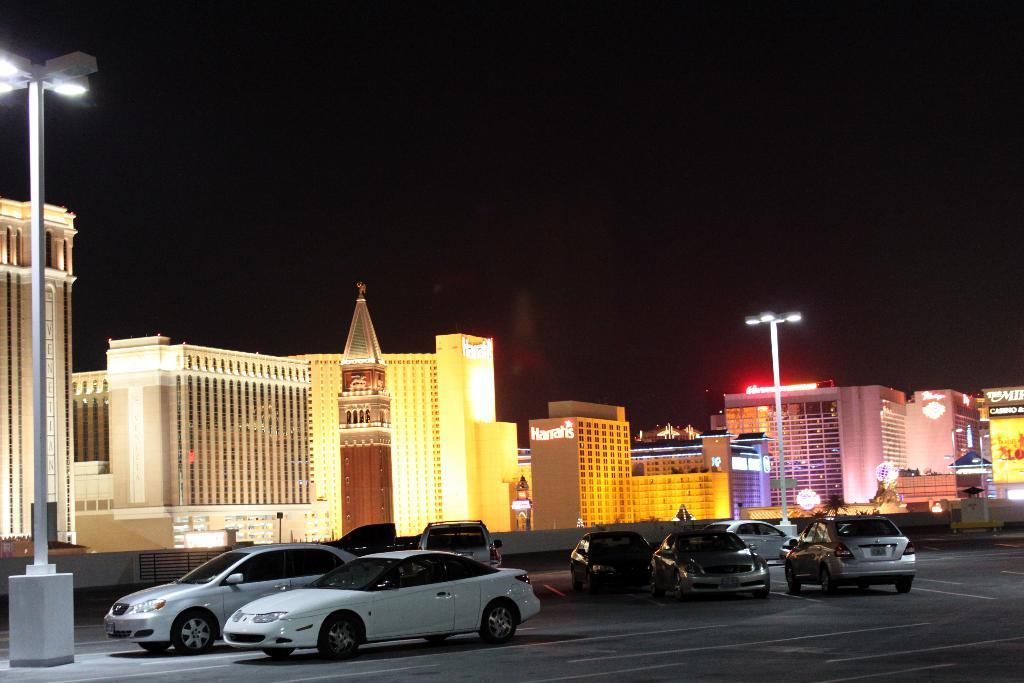What type of vehicles can be seen on the road in the image? There are cars on the road in the image. What structures are present alongside the road? There are light poles in the image. What can be seen in the distance in the image? There are buildings in the background of the image. Is there any text visible on the buildings in the image? Yes, text is written on the buildings in the image. What type of chair is placed on the roof of the building in the image? There is no chair or roof of a building present in the image. 